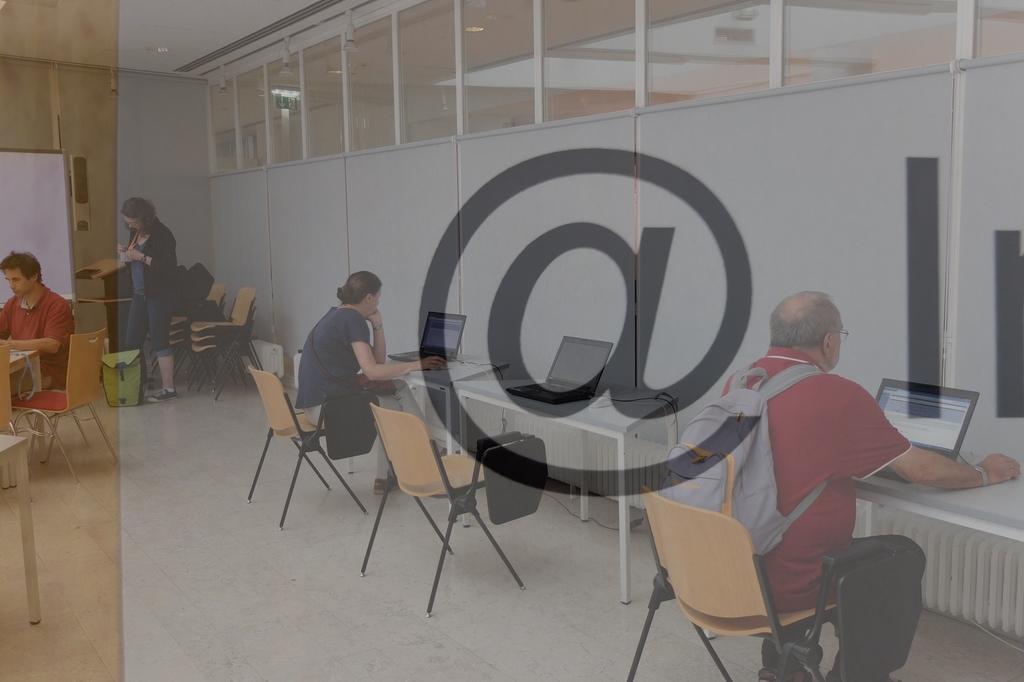Please provide a concise description of this image. In this image I can see glass walls through which I can see few people sitting on the chairs and operating laptops. A person is standing at the back. There is a white board and chairs at the back. 